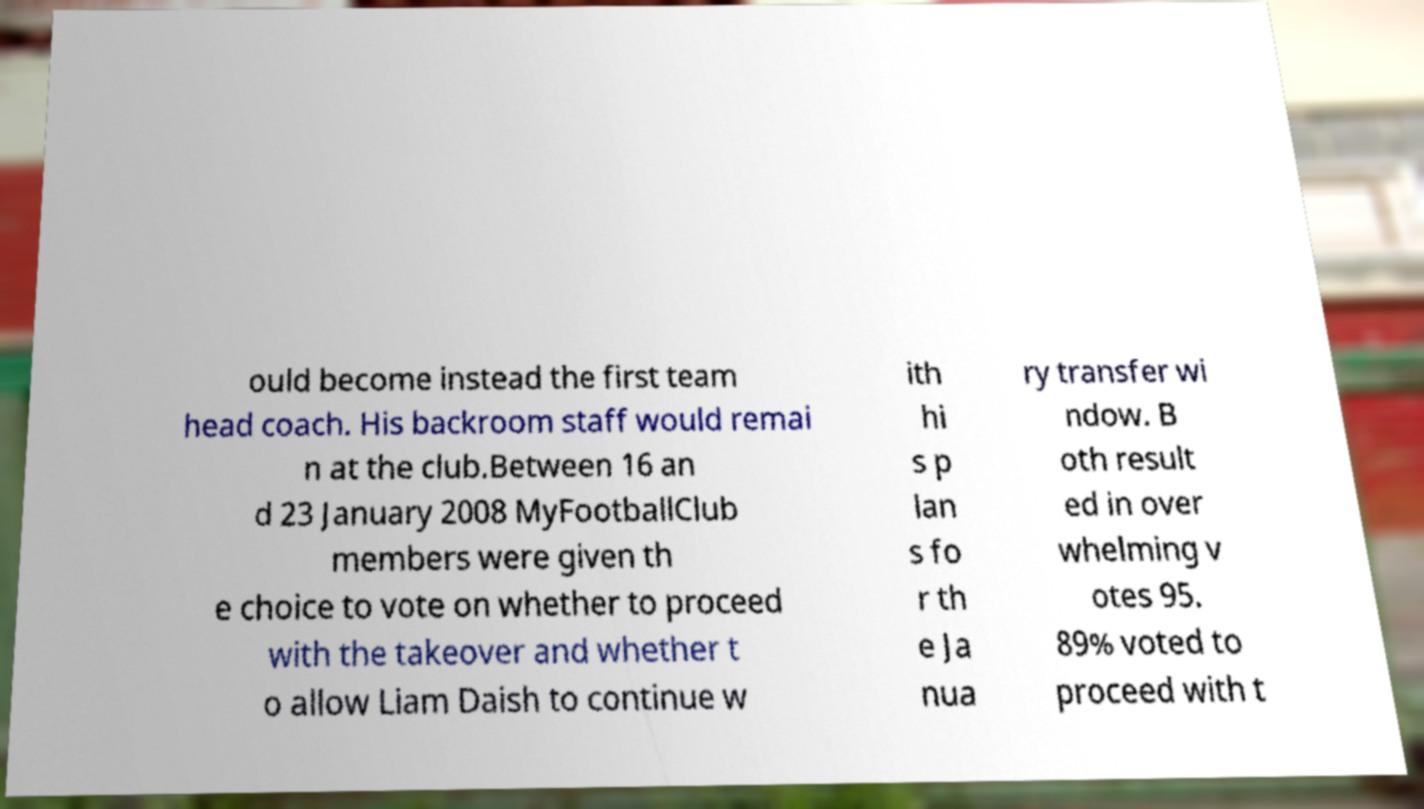Can you read and provide the text displayed in the image?This photo seems to have some interesting text. Can you extract and type it out for me? ould become instead the first team head coach. His backroom staff would remai n at the club.Between 16 an d 23 January 2008 MyFootballClub members were given th e choice to vote on whether to proceed with the takeover and whether t o allow Liam Daish to continue w ith hi s p lan s fo r th e Ja nua ry transfer wi ndow. B oth result ed in over whelming v otes 95. 89% voted to proceed with t 